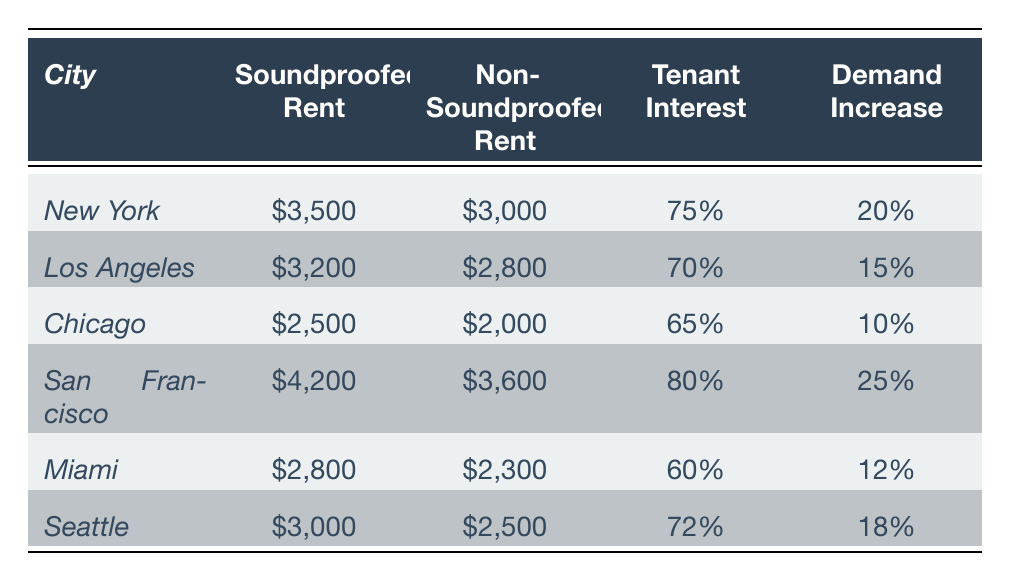What is the average rent for soundproofed properties in Chicago? The table shows that the average rent for soundproofed properties in Chicago is $2,500.
Answer: $2,500 Which city has the highest tenant interest in soundproofing? Looking at the "Tenant Interest" column, San Francisco has the highest tenant interest at 80%.
Answer: San Francisco What is the difference in average rent between soundproofed and non-soundproofed properties in Los Angeles? The average rent for soundproofed properties is $3,200 and for non-soundproofed is $2,800. The difference is $3,200 - $2,800 = $400.
Answer: $400 Which city shows the greatest increase in demand for soundproofed properties? San Francisco shows the highest increase in demand at 25%, compared to the others.
Answer: San Francisco What is the average tenant interest in soundproofing across all cities? To calculate the average tenant interest, add all percentages (75% + 70% + 65% + 80% + 60% + 72%) = 422%, and then divide by the number of cities (6), which gives 422% / 6 ≈ 70.33%.
Answer: 70.33% Is the average rent for soundproofed properties higher than for non-soundproofed in all cities? A comparison of the rents shows that in each city, the rent for soundproofed properties is higher than for non-soundproofed properties, confirming this statement.
Answer: Yes How much does the average rent for soundproofed properties in Seattle exceed that of non-soundproofed properties? The average rent for soundproofed properties in Seattle is $3,000, and non-soundproofed is $2,500. The difference is $3,000 - $2,500 = $500.
Answer: $500 Which city has the lowest tenant interest in soundproofing? Chicago has the lowest tenant interest in soundproofing at 65%, as per the "Tenant Interest" column.
Answer: Chicago What is the percentage increase in demand for soundproofed properties in Miami compared to Chicago? Miami has a demand increase of 12% and Chicago has 10%. The increase is 12% - 10% = 2%.
Answer: 2% What is the average rent for non-soundproofed properties across all cities? To find the average, sum the non-soundproofed rents ($3,000 + $2,800 + $2,000 + $3,600 + $2,300 + $2,500 = $16,200) and divide by 6, giving $16,200 / 6 = $2,700.
Answer: $2,700 Which city has the largest gap between soundproofed and non-soundproofed rents, and what is that gap? Comparing the differences, San Francisco has the largest gap: $4,200 - $3,600 = $600.
Answer: San Francisco, $600 